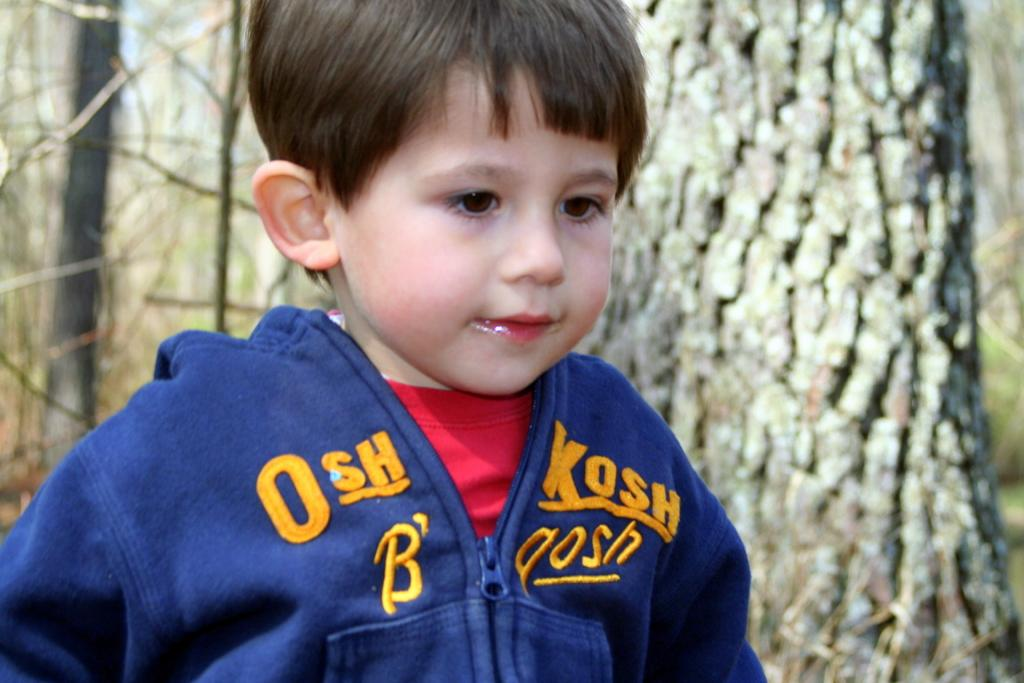Who is the main subject in the picture? There is a boy in the picture. What can be seen in the background of the picture? Tree trunks are visible in the background of the picture. Is the squirrel holding a ticket in the picture? There is no squirrel present in the picture, so it cannot be holding a ticket. 